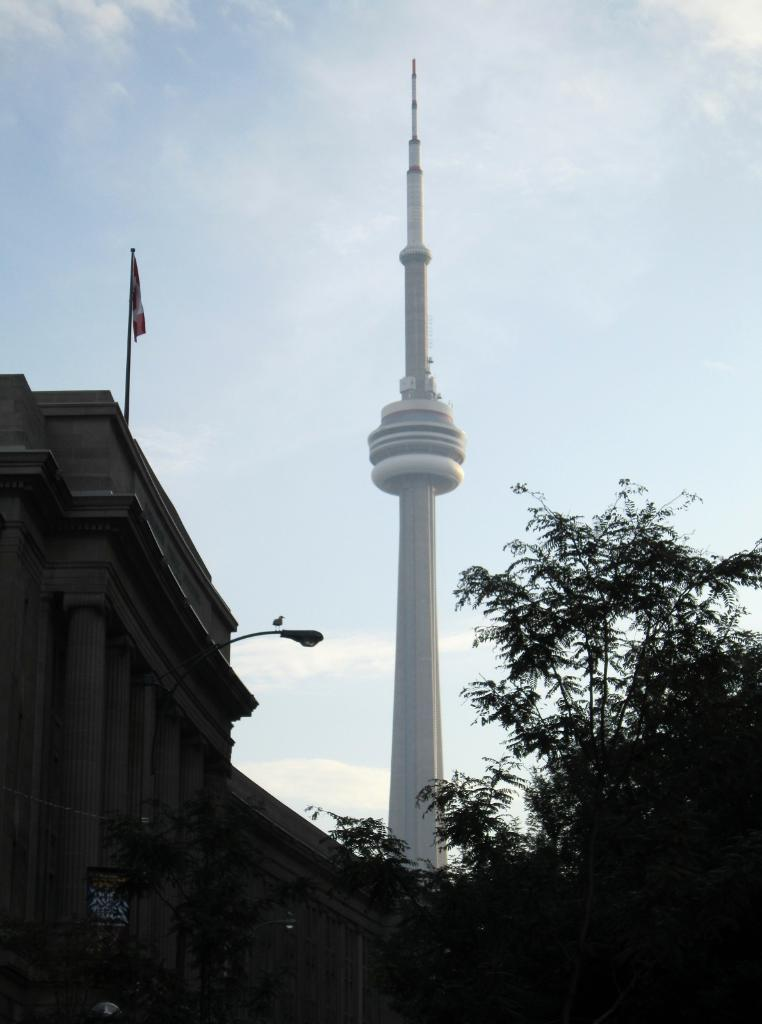What is the main structure in the center of the image? There is a tower in the center of the image. What can be seen on the left side of the image? There is a building with a flag on the left side of the image. What type of vegetation is on the right side of the image? There is a tree on the right side of the image. Can you hear the goldfish swimming in the image? There are no goldfish present in the image, so it is not possible to hear them swimming. How many people are walking in the image? The image does not show any people walking, so it is not possible to determine the number of people walking. 